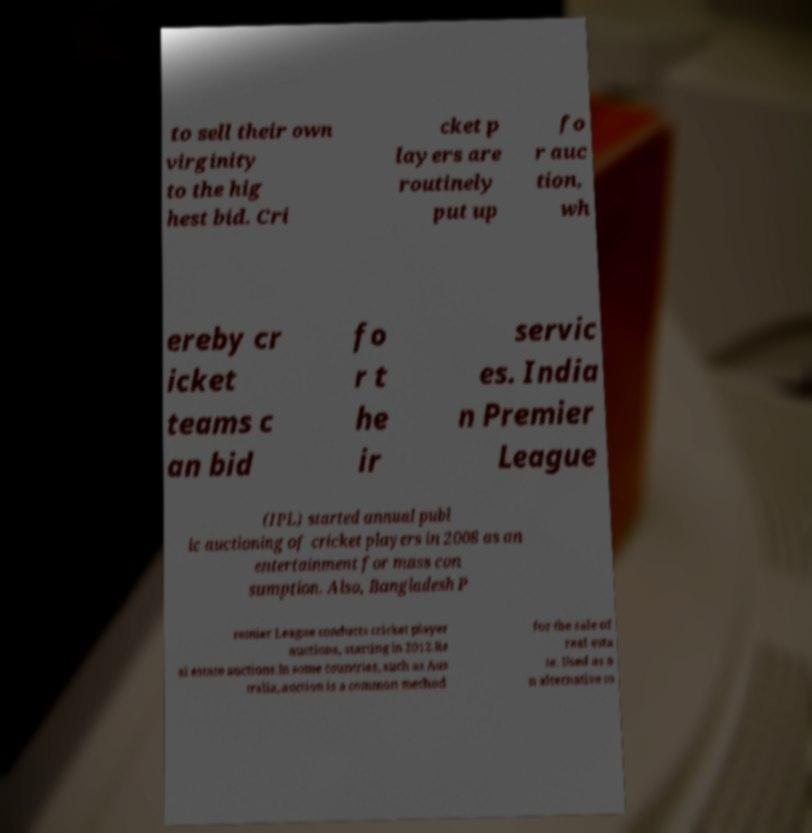What messages or text are displayed in this image? I need them in a readable, typed format. to sell their own virginity to the hig hest bid. Cri cket p layers are routinely put up fo r auc tion, wh ereby cr icket teams c an bid fo r t he ir servic es. India n Premier League (IPL) started annual publ ic auctioning of cricket players in 2008 as an entertainment for mass con sumption. Also, Bangladesh P remier League conducts cricket player auctions, starting in 2012.Re al estate auctions.In some countries, such as Aus tralia, auction is a common method for the sale of real esta te. Used as a n alternative to 